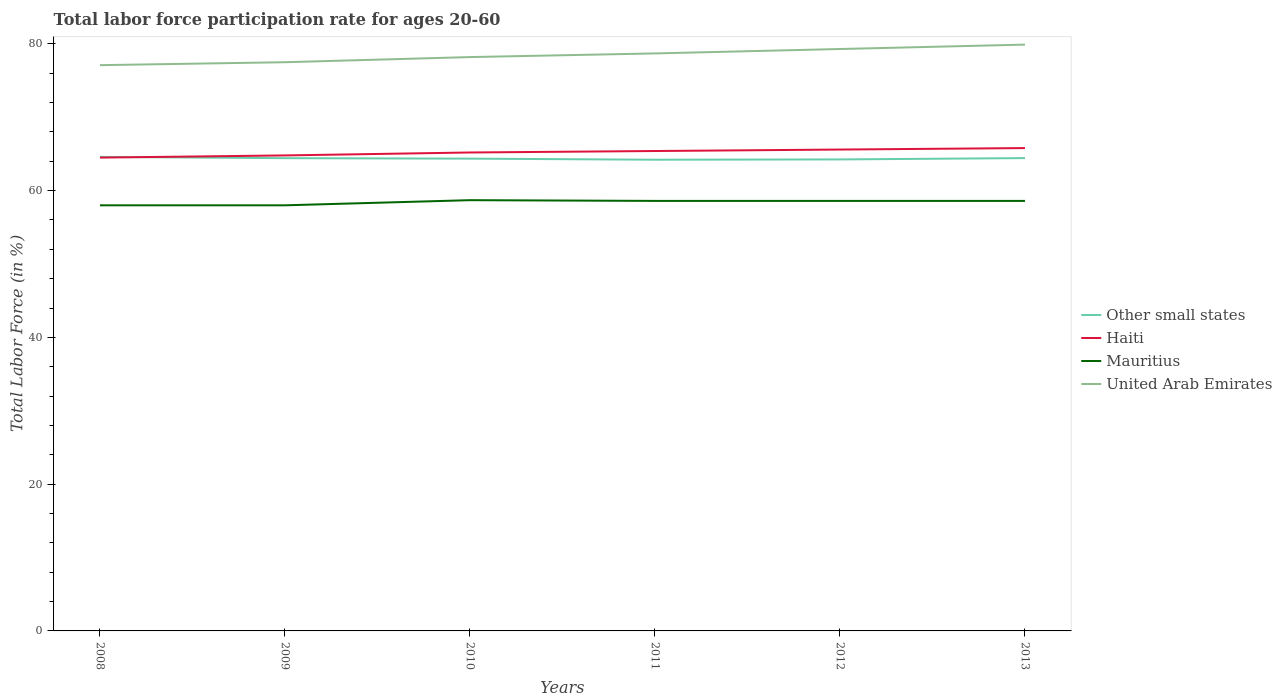Is the number of lines equal to the number of legend labels?
Give a very brief answer. Yes. Across all years, what is the maximum labor force participation rate in United Arab Emirates?
Offer a terse response. 77.1. In which year was the labor force participation rate in Mauritius maximum?
Give a very brief answer. 2008. What is the total labor force participation rate in United Arab Emirates in the graph?
Ensure brevity in your answer.  -1.8. What is the difference between the highest and the second highest labor force participation rate in Other small states?
Keep it short and to the point. 0.38. Is the labor force participation rate in United Arab Emirates strictly greater than the labor force participation rate in Haiti over the years?
Ensure brevity in your answer.  No. Are the values on the major ticks of Y-axis written in scientific E-notation?
Give a very brief answer. No. Does the graph contain any zero values?
Offer a terse response. No. Where does the legend appear in the graph?
Your answer should be very brief. Center right. How are the legend labels stacked?
Keep it short and to the point. Vertical. What is the title of the graph?
Offer a terse response. Total labor force participation rate for ages 20-60. Does "Curacao" appear as one of the legend labels in the graph?
Provide a short and direct response. No. What is the label or title of the X-axis?
Give a very brief answer. Years. What is the Total Labor Force (in %) of Other small states in 2008?
Your answer should be very brief. 64.6. What is the Total Labor Force (in %) in Haiti in 2008?
Offer a very short reply. 64.5. What is the Total Labor Force (in %) in Mauritius in 2008?
Ensure brevity in your answer.  58. What is the Total Labor Force (in %) of United Arab Emirates in 2008?
Ensure brevity in your answer.  77.1. What is the Total Labor Force (in %) in Other small states in 2009?
Your response must be concise. 64.42. What is the Total Labor Force (in %) in Haiti in 2009?
Provide a succinct answer. 64.8. What is the Total Labor Force (in %) of Mauritius in 2009?
Keep it short and to the point. 58. What is the Total Labor Force (in %) of United Arab Emirates in 2009?
Provide a succinct answer. 77.5. What is the Total Labor Force (in %) of Other small states in 2010?
Make the answer very short. 64.36. What is the Total Labor Force (in %) of Haiti in 2010?
Provide a succinct answer. 65.2. What is the Total Labor Force (in %) of Mauritius in 2010?
Make the answer very short. 58.7. What is the Total Labor Force (in %) in United Arab Emirates in 2010?
Offer a very short reply. 78.2. What is the Total Labor Force (in %) of Other small states in 2011?
Offer a very short reply. 64.21. What is the Total Labor Force (in %) of Haiti in 2011?
Offer a very short reply. 65.4. What is the Total Labor Force (in %) in Mauritius in 2011?
Keep it short and to the point. 58.6. What is the Total Labor Force (in %) of United Arab Emirates in 2011?
Provide a short and direct response. 78.7. What is the Total Labor Force (in %) of Other small states in 2012?
Make the answer very short. 64.25. What is the Total Labor Force (in %) of Haiti in 2012?
Offer a very short reply. 65.6. What is the Total Labor Force (in %) in Mauritius in 2012?
Your answer should be very brief. 58.6. What is the Total Labor Force (in %) in United Arab Emirates in 2012?
Provide a succinct answer. 79.3. What is the Total Labor Force (in %) in Other small states in 2013?
Provide a short and direct response. 64.44. What is the Total Labor Force (in %) of Haiti in 2013?
Offer a terse response. 65.8. What is the Total Labor Force (in %) in Mauritius in 2013?
Ensure brevity in your answer.  58.6. What is the Total Labor Force (in %) in United Arab Emirates in 2013?
Provide a short and direct response. 79.9. Across all years, what is the maximum Total Labor Force (in %) in Other small states?
Offer a very short reply. 64.6. Across all years, what is the maximum Total Labor Force (in %) in Haiti?
Ensure brevity in your answer.  65.8. Across all years, what is the maximum Total Labor Force (in %) of Mauritius?
Ensure brevity in your answer.  58.7. Across all years, what is the maximum Total Labor Force (in %) in United Arab Emirates?
Your answer should be compact. 79.9. Across all years, what is the minimum Total Labor Force (in %) in Other small states?
Your answer should be very brief. 64.21. Across all years, what is the minimum Total Labor Force (in %) of Haiti?
Make the answer very short. 64.5. Across all years, what is the minimum Total Labor Force (in %) of Mauritius?
Provide a succinct answer. 58. Across all years, what is the minimum Total Labor Force (in %) of United Arab Emirates?
Your answer should be very brief. 77.1. What is the total Total Labor Force (in %) in Other small states in the graph?
Provide a succinct answer. 386.29. What is the total Total Labor Force (in %) of Haiti in the graph?
Your response must be concise. 391.3. What is the total Total Labor Force (in %) of Mauritius in the graph?
Make the answer very short. 350.5. What is the total Total Labor Force (in %) of United Arab Emirates in the graph?
Give a very brief answer. 470.7. What is the difference between the Total Labor Force (in %) in Other small states in 2008 and that in 2009?
Your answer should be compact. 0.17. What is the difference between the Total Labor Force (in %) of Mauritius in 2008 and that in 2009?
Provide a succinct answer. 0. What is the difference between the Total Labor Force (in %) of United Arab Emirates in 2008 and that in 2009?
Provide a short and direct response. -0.4. What is the difference between the Total Labor Force (in %) in Other small states in 2008 and that in 2010?
Offer a very short reply. 0.24. What is the difference between the Total Labor Force (in %) of Haiti in 2008 and that in 2010?
Offer a terse response. -0.7. What is the difference between the Total Labor Force (in %) in Mauritius in 2008 and that in 2010?
Offer a terse response. -0.7. What is the difference between the Total Labor Force (in %) in Other small states in 2008 and that in 2011?
Ensure brevity in your answer.  0.38. What is the difference between the Total Labor Force (in %) in Mauritius in 2008 and that in 2011?
Provide a succinct answer. -0.6. What is the difference between the Total Labor Force (in %) in United Arab Emirates in 2008 and that in 2011?
Provide a short and direct response. -1.6. What is the difference between the Total Labor Force (in %) of Other small states in 2008 and that in 2012?
Make the answer very short. 0.34. What is the difference between the Total Labor Force (in %) in Haiti in 2008 and that in 2012?
Your answer should be compact. -1.1. What is the difference between the Total Labor Force (in %) in Other small states in 2008 and that in 2013?
Keep it short and to the point. 0.16. What is the difference between the Total Labor Force (in %) in Haiti in 2008 and that in 2013?
Give a very brief answer. -1.3. What is the difference between the Total Labor Force (in %) in Mauritius in 2008 and that in 2013?
Your answer should be very brief. -0.6. What is the difference between the Total Labor Force (in %) of United Arab Emirates in 2008 and that in 2013?
Your answer should be compact. -2.8. What is the difference between the Total Labor Force (in %) in Other small states in 2009 and that in 2010?
Make the answer very short. 0.06. What is the difference between the Total Labor Force (in %) in Haiti in 2009 and that in 2010?
Your answer should be very brief. -0.4. What is the difference between the Total Labor Force (in %) in United Arab Emirates in 2009 and that in 2010?
Provide a succinct answer. -0.7. What is the difference between the Total Labor Force (in %) of Other small states in 2009 and that in 2011?
Ensure brevity in your answer.  0.21. What is the difference between the Total Labor Force (in %) in United Arab Emirates in 2009 and that in 2011?
Offer a terse response. -1.2. What is the difference between the Total Labor Force (in %) of Other small states in 2009 and that in 2012?
Give a very brief answer. 0.17. What is the difference between the Total Labor Force (in %) of Haiti in 2009 and that in 2012?
Offer a terse response. -0.8. What is the difference between the Total Labor Force (in %) of Mauritius in 2009 and that in 2012?
Your answer should be very brief. -0.6. What is the difference between the Total Labor Force (in %) in United Arab Emirates in 2009 and that in 2012?
Your answer should be very brief. -1.8. What is the difference between the Total Labor Force (in %) in Other small states in 2009 and that in 2013?
Provide a succinct answer. -0.01. What is the difference between the Total Labor Force (in %) in Haiti in 2009 and that in 2013?
Your answer should be compact. -1. What is the difference between the Total Labor Force (in %) of Other small states in 2010 and that in 2011?
Offer a very short reply. 0.15. What is the difference between the Total Labor Force (in %) in Mauritius in 2010 and that in 2011?
Offer a very short reply. 0.1. What is the difference between the Total Labor Force (in %) of United Arab Emirates in 2010 and that in 2011?
Keep it short and to the point. -0.5. What is the difference between the Total Labor Force (in %) of Other small states in 2010 and that in 2012?
Your answer should be very brief. 0.11. What is the difference between the Total Labor Force (in %) of United Arab Emirates in 2010 and that in 2012?
Ensure brevity in your answer.  -1.1. What is the difference between the Total Labor Force (in %) of Other small states in 2010 and that in 2013?
Keep it short and to the point. -0.07. What is the difference between the Total Labor Force (in %) of Haiti in 2010 and that in 2013?
Your answer should be very brief. -0.6. What is the difference between the Total Labor Force (in %) in United Arab Emirates in 2010 and that in 2013?
Keep it short and to the point. -1.7. What is the difference between the Total Labor Force (in %) of Other small states in 2011 and that in 2012?
Make the answer very short. -0.04. What is the difference between the Total Labor Force (in %) of Mauritius in 2011 and that in 2012?
Give a very brief answer. 0. What is the difference between the Total Labor Force (in %) of United Arab Emirates in 2011 and that in 2012?
Keep it short and to the point. -0.6. What is the difference between the Total Labor Force (in %) in Other small states in 2011 and that in 2013?
Your answer should be very brief. -0.22. What is the difference between the Total Labor Force (in %) of Haiti in 2011 and that in 2013?
Provide a succinct answer. -0.4. What is the difference between the Total Labor Force (in %) in United Arab Emirates in 2011 and that in 2013?
Make the answer very short. -1.2. What is the difference between the Total Labor Force (in %) of Other small states in 2012 and that in 2013?
Your answer should be very brief. -0.18. What is the difference between the Total Labor Force (in %) in Haiti in 2012 and that in 2013?
Provide a short and direct response. -0.2. What is the difference between the Total Labor Force (in %) of Mauritius in 2012 and that in 2013?
Keep it short and to the point. 0. What is the difference between the Total Labor Force (in %) in Other small states in 2008 and the Total Labor Force (in %) in Haiti in 2009?
Keep it short and to the point. -0.2. What is the difference between the Total Labor Force (in %) in Other small states in 2008 and the Total Labor Force (in %) in Mauritius in 2009?
Make the answer very short. 6.6. What is the difference between the Total Labor Force (in %) in Other small states in 2008 and the Total Labor Force (in %) in United Arab Emirates in 2009?
Give a very brief answer. -12.9. What is the difference between the Total Labor Force (in %) in Haiti in 2008 and the Total Labor Force (in %) in United Arab Emirates in 2009?
Provide a short and direct response. -13. What is the difference between the Total Labor Force (in %) of Mauritius in 2008 and the Total Labor Force (in %) of United Arab Emirates in 2009?
Provide a short and direct response. -19.5. What is the difference between the Total Labor Force (in %) of Other small states in 2008 and the Total Labor Force (in %) of Haiti in 2010?
Provide a succinct answer. -0.6. What is the difference between the Total Labor Force (in %) in Other small states in 2008 and the Total Labor Force (in %) in Mauritius in 2010?
Provide a short and direct response. 5.9. What is the difference between the Total Labor Force (in %) in Other small states in 2008 and the Total Labor Force (in %) in United Arab Emirates in 2010?
Your answer should be compact. -13.6. What is the difference between the Total Labor Force (in %) of Haiti in 2008 and the Total Labor Force (in %) of Mauritius in 2010?
Provide a short and direct response. 5.8. What is the difference between the Total Labor Force (in %) of Haiti in 2008 and the Total Labor Force (in %) of United Arab Emirates in 2010?
Keep it short and to the point. -13.7. What is the difference between the Total Labor Force (in %) of Mauritius in 2008 and the Total Labor Force (in %) of United Arab Emirates in 2010?
Make the answer very short. -20.2. What is the difference between the Total Labor Force (in %) of Other small states in 2008 and the Total Labor Force (in %) of Haiti in 2011?
Provide a succinct answer. -0.8. What is the difference between the Total Labor Force (in %) in Other small states in 2008 and the Total Labor Force (in %) in Mauritius in 2011?
Ensure brevity in your answer.  6. What is the difference between the Total Labor Force (in %) in Other small states in 2008 and the Total Labor Force (in %) in United Arab Emirates in 2011?
Your answer should be compact. -14.1. What is the difference between the Total Labor Force (in %) in Mauritius in 2008 and the Total Labor Force (in %) in United Arab Emirates in 2011?
Provide a succinct answer. -20.7. What is the difference between the Total Labor Force (in %) in Other small states in 2008 and the Total Labor Force (in %) in Haiti in 2012?
Your response must be concise. -1. What is the difference between the Total Labor Force (in %) in Other small states in 2008 and the Total Labor Force (in %) in Mauritius in 2012?
Provide a succinct answer. 6. What is the difference between the Total Labor Force (in %) in Other small states in 2008 and the Total Labor Force (in %) in United Arab Emirates in 2012?
Provide a succinct answer. -14.7. What is the difference between the Total Labor Force (in %) in Haiti in 2008 and the Total Labor Force (in %) in Mauritius in 2012?
Give a very brief answer. 5.9. What is the difference between the Total Labor Force (in %) in Haiti in 2008 and the Total Labor Force (in %) in United Arab Emirates in 2012?
Make the answer very short. -14.8. What is the difference between the Total Labor Force (in %) in Mauritius in 2008 and the Total Labor Force (in %) in United Arab Emirates in 2012?
Ensure brevity in your answer.  -21.3. What is the difference between the Total Labor Force (in %) of Other small states in 2008 and the Total Labor Force (in %) of Haiti in 2013?
Keep it short and to the point. -1.2. What is the difference between the Total Labor Force (in %) in Other small states in 2008 and the Total Labor Force (in %) in Mauritius in 2013?
Make the answer very short. 6. What is the difference between the Total Labor Force (in %) of Other small states in 2008 and the Total Labor Force (in %) of United Arab Emirates in 2013?
Provide a succinct answer. -15.3. What is the difference between the Total Labor Force (in %) of Haiti in 2008 and the Total Labor Force (in %) of United Arab Emirates in 2013?
Your answer should be very brief. -15.4. What is the difference between the Total Labor Force (in %) in Mauritius in 2008 and the Total Labor Force (in %) in United Arab Emirates in 2013?
Offer a very short reply. -21.9. What is the difference between the Total Labor Force (in %) of Other small states in 2009 and the Total Labor Force (in %) of Haiti in 2010?
Keep it short and to the point. -0.78. What is the difference between the Total Labor Force (in %) of Other small states in 2009 and the Total Labor Force (in %) of Mauritius in 2010?
Ensure brevity in your answer.  5.72. What is the difference between the Total Labor Force (in %) of Other small states in 2009 and the Total Labor Force (in %) of United Arab Emirates in 2010?
Your answer should be compact. -13.78. What is the difference between the Total Labor Force (in %) of Haiti in 2009 and the Total Labor Force (in %) of Mauritius in 2010?
Ensure brevity in your answer.  6.1. What is the difference between the Total Labor Force (in %) of Mauritius in 2009 and the Total Labor Force (in %) of United Arab Emirates in 2010?
Keep it short and to the point. -20.2. What is the difference between the Total Labor Force (in %) in Other small states in 2009 and the Total Labor Force (in %) in Haiti in 2011?
Offer a terse response. -0.98. What is the difference between the Total Labor Force (in %) in Other small states in 2009 and the Total Labor Force (in %) in Mauritius in 2011?
Make the answer very short. 5.82. What is the difference between the Total Labor Force (in %) of Other small states in 2009 and the Total Labor Force (in %) of United Arab Emirates in 2011?
Keep it short and to the point. -14.28. What is the difference between the Total Labor Force (in %) of Haiti in 2009 and the Total Labor Force (in %) of Mauritius in 2011?
Your answer should be very brief. 6.2. What is the difference between the Total Labor Force (in %) in Mauritius in 2009 and the Total Labor Force (in %) in United Arab Emirates in 2011?
Provide a succinct answer. -20.7. What is the difference between the Total Labor Force (in %) in Other small states in 2009 and the Total Labor Force (in %) in Haiti in 2012?
Offer a very short reply. -1.18. What is the difference between the Total Labor Force (in %) of Other small states in 2009 and the Total Labor Force (in %) of Mauritius in 2012?
Give a very brief answer. 5.82. What is the difference between the Total Labor Force (in %) in Other small states in 2009 and the Total Labor Force (in %) in United Arab Emirates in 2012?
Your answer should be compact. -14.88. What is the difference between the Total Labor Force (in %) in Haiti in 2009 and the Total Labor Force (in %) in United Arab Emirates in 2012?
Your answer should be very brief. -14.5. What is the difference between the Total Labor Force (in %) in Mauritius in 2009 and the Total Labor Force (in %) in United Arab Emirates in 2012?
Ensure brevity in your answer.  -21.3. What is the difference between the Total Labor Force (in %) in Other small states in 2009 and the Total Labor Force (in %) in Haiti in 2013?
Ensure brevity in your answer.  -1.38. What is the difference between the Total Labor Force (in %) in Other small states in 2009 and the Total Labor Force (in %) in Mauritius in 2013?
Make the answer very short. 5.82. What is the difference between the Total Labor Force (in %) in Other small states in 2009 and the Total Labor Force (in %) in United Arab Emirates in 2013?
Ensure brevity in your answer.  -15.48. What is the difference between the Total Labor Force (in %) of Haiti in 2009 and the Total Labor Force (in %) of United Arab Emirates in 2013?
Offer a very short reply. -15.1. What is the difference between the Total Labor Force (in %) of Mauritius in 2009 and the Total Labor Force (in %) of United Arab Emirates in 2013?
Your answer should be compact. -21.9. What is the difference between the Total Labor Force (in %) in Other small states in 2010 and the Total Labor Force (in %) in Haiti in 2011?
Keep it short and to the point. -1.04. What is the difference between the Total Labor Force (in %) in Other small states in 2010 and the Total Labor Force (in %) in Mauritius in 2011?
Provide a short and direct response. 5.76. What is the difference between the Total Labor Force (in %) in Other small states in 2010 and the Total Labor Force (in %) in United Arab Emirates in 2011?
Give a very brief answer. -14.34. What is the difference between the Total Labor Force (in %) in Haiti in 2010 and the Total Labor Force (in %) in Mauritius in 2011?
Make the answer very short. 6.6. What is the difference between the Total Labor Force (in %) of Haiti in 2010 and the Total Labor Force (in %) of United Arab Emirates in 2011?
Provide a succinct answer. -13.5. What is the difference between the Total Labor Force (in %) in Other small states in 2010 and the Total Labor Force (in %) in Haiti in 2012?
Provide a short and direct response. -1.24. What is the difference between the Total Labor Force (in %) of Other small states in 2010 and the Total Labor Force (in %) of Mauritius in 2012?
Give a very brief answer. 5.76. What is the difference between the Total Labor Force (in %) of Other small states in 2010 and the Total Labor Force (in %) of United Arab Emirates in 2012?
Keep it short and to the point. -14.94. What is the difference between the Total Labor Force (in %) in Haiti in 2010 and the Total Labor Force (in %) in United Arab Emirates in 2012?
Make the answer very short. -14.1. What is the difference between the Total Labor Force (in %) of Mauritius in 2010 and the Total Labor Force (in %) of United Arab Emirates in 2012?
Offer a terse response. -20.6. What is the difference between the Total Labor Force (in %) in Other small states in 2010 and the Total Labor Force (in %) in Haiti in 2013?
Keep it short and to the point. -1.44. What is the difference between the Total Labor Force (in %) in Other small states in 2010 and the Total Labor Force (in %) in Mauritius in 2013?
Provide a short and direct response. 5.76. What is the difference between the Total Labor Force (in %) in Other small states in 2010 and the Total Labor Force (in %) in United Arab Emirates in 2013?
Your response must be concise. -15.54. What is the difference between the Total Labor Force (in %) of Haiti in 2010 and the Total Labor Force (in %) of United Arab Emirates in 2013?
Keep it short and to the point. -14.7. What is the difference between the Total Labor Force (in %) in Mauritius in 2010 and the Total Labor Force (in %) in United Arab Emirates in 2013?
Ensure brevity in your answer.  -21.2. What is the difference between the Total Labor Force (in %) of Other small states in 2011 and the Total Labor Force (in %) of Haiti in 2012?
Provide a short and direct response. -1.39. What is the difference between the Total Labor Force (in %) of Other small states in 2011 and the Total Labor Force (in %) of Mauritius in 2012?
Make the answer very short. 5.61. What is the difference between the Total Labor Force (in %) of Other small states in 2011 and the Total Labor Force (in %) of United Arab Emirates in 2012?
Provide a succinct answer. -15.09. What is the difference between the Total Labor Force (in %) of Haiti in 2011 and the Total Labor Force (in %) of United Arab Emirates in 2012?
Ensure brevity in your answer.  -13.9. What is the difference between the Total Labor Force (in %) of Mauritius in 2011 and the Total Labor Force (in %) of United Arab Emirates in 2012?
Offer a terse response. -20.7. What is the difference between the Total Labor Force (in %) in Other small states in 2011 and the Total Labor Force (in %) in Haiti in 2013?
Offer a terse response. -1.59. What is the difference between the Total Labor Force (in %) of Other small states in 2011 and the Total Labor Force (in %) of Mauritius in 2013?
Keep it short and to the point. 5.61. What is the difference between the Total Labor Force (in %) of Other small states in 2011 and the Total Labor Force (in %) of United Arab Emirates in 2013?
Provide a succinct answer. -15.69. What is the difference between the Total Labor Force (in %) of Haiti in 2011 and the Total Labor Force (in %) of Mauritius in 2013?
Make the answer very short. 6.8. What is the difference between the Total Labor Force (in %) of Mauritius in 2011 and the Total Labor Force (in %) of United Arab Emirates in 2013?
Keep it short and to the point. -21.3. What is the difference between the Total Labor Force (in %) of Other small states in 2012 and the Total Labor Force (in %) of Haiti in 2013?
Offer a very short reply. -1.55. What is the difference between the Total Labor Force (in %) in Other small states in 2012 and the Total Labor Force (in %) in Mauritius in 2013?
Keep it short and to the point. 5.65. What is the difference between the Total Labor Force (in %) in Other small states in 2012 and the Total Labor Force (in %) in United Arab Emirates in 2013?
Your response must be concise. -15.65. What is the difference between the Total Labor Force (in %) of Haiti in 2012 and the Total Labor Force (in %) of Mauritius in 2013?
Make the answer very short. 7. What is the difference between the Total Labor Force (in %) of Haiti in 2012 and the Total Labor Force (in %) of United Arab Emirates in 2013?
Provide a short and direct response. -14.3. What is the difference between the Total Labor Force (in %) in Mauritius in 2012 and the Total Labor Force (in %) in United Arab Emirates in 2013?
Your answer should be compact. -21.3. What is the average Total Labor Force (in %) of Other small states per year?
Your answer should be very brief. 64.38. What is the average Total Labor Force (in %) in Haiti per year?
Ensure brevity in your answer.  65.22. What is the average Total Labor Force (in %) in Mauritius per year?
Give a very brief answer. 58.42. What is the average Total Labor Force (in %) of United Arab Emirates per year?
Give a very brief answer. 78.45. In the year 2008, what is the difference between the Total Labor Force (in %) in Other small states and Total Labor Force (in %) in Haiti?
Provide a succinct answer. 0.1. In the year 2008, what is the difference between the Total Labor Force (in %) of Other small states and Total Labor Force (in %) of Mauritius?
Give a very brief answer. 6.6. In the year 2008, what is the difference between the Total Labor Force (in %) of Other small states and Total Labor Force (in %) of United Arab Emirates?
Your answer should be very brief. -12.5. In the year 2008, what is the difference between the Total Labor Force (in %) of Mauritius and Total Labor Force (in %) of United Arab Emirates?
Your answer should be very brief. -19.1. In the year 2009, what is the difference between the Total Labor Force (in %) in Other small states and Total Labor Force (in %) in Haiti?
Make the answer very short. -0.38. In the year 2009, what is the difference between the Total Labor Force (in %) of Other small states and Total Labor Force (in %) of Mauritius?
Offer a terse response. 6.42. In the year 2009, what is the difference between the Total Labor Force (in %) in Other small states and Total Labor Force (in %) in United Arab Emirates?
Your response must be concise. -13.08. In the year 2009, what is the difference between the Total Labor Force (in %) of Haiti and Total Labor Force (in %) of United Arab Emirates?
Your response must be concise. -12.7. In the year 2009, what is the difference between the Total Labor Force (in %) in Mauritius and Total Labor Force (in %) in United Arab Emirates?
Offer a very short reply. -19.5. In the year 2010, what is the difference between the Total Labor Force (in %) in Other small states and Total Labor Force (in %) in Haiti?
Make the answer very short. -0.84. In the year 2010, what is the difference between the Total Labor Force (in %) of Other small states and Total Labor Force (in %) of Mauritius?
Keep it short and to the point. 5.66. In the year 2010, what is the difference between the Total Labor Force (in %) of Other small states and Total Labor Force (in %) of United Arab Emirates?
Your response must be concise. -13.84. In the year 2010, what is the difference between the Total Labor Force (in %) of Mauritius and Total Labor Force (in %) of United Arab Emirates?
Your response must be concise. -19.5. In the year 2011, what is the difference between the Total Labor Force (in %) in Other small states and Total Labor Force (in %) in Haiti?
Give a very brief answer. -1.19. In the year 2011, what is the difference between the Total Labor Force (in %) in Other small states and Total Labor Force (in %) in Mauritius?
Provide a succinct answer. 5.61. In the year 2011, what is the difference between the Total Labor Force (in %) in Other small states and Total Labor Force (in %) in United Arab Emirates?
Your response must be concise. -14.49. In the year 2011, what is the difference between the Total Labor Force (in %) of Haiti and Total Labor Force (in %) of Mauritius?
Provide a succinct answer. 6.8. In the year 2011, what is the difference between the Total Labor Force (in %) of Haiti and Total Labor Force (in %) of United Arab Emirates?
Your response must be concise. -13.3. In the year 2011, what is the difference between the Total Labor Force (in %) of Mauritius and Total Labor Force (in %) of United Arab Emirates?
Your answer should be compact. -20.1. In the year 2012, what is the difference between the Total Labor Force (in %) in Other small states and Total Labor Force (in %) in Haiti?
Offer a very short reply. -1.35. In the year 2012, what is the difference between the Total Labor Force (in %) of Other small states and Total Labor Force (in %) of Mauritius?
Your response must be concise. 5.65. In the year 2012, what is the difference between the Total Labor Force (in %) of Other small states and Total Labor Force (in %) of United Arab Emirates?
Your answer should be compact. -15.05. In the year 2012, what is the difference between the Total Labor Force (in %) in Haiti and Total Labor Force (in %) in Mauritius?
Make the answer very short. 7. In the year 2012, what is the difference between the Total Labor Force (in %) in Haiti and Total Labor Force (in %) in United Arab Emirates?
Make the answer very short. -13.7. In the year 2012, what is the difference between the Total Labor Force (in %) in Mauritius and Total Labor Force (in %) in United Arab Emirates?
Your answer should be very brief. -20.7. In the year 2013, what is the difference between the Total Labor Force (in %) in Other small states and Total Labor Force (in %) in Haiti?
Make the answer very short. -1.36. In the year 2013, what is the difference between the Total Labor Force (in %) of Other small states and Total Labor Force (in %) of Mauritius?
Your answer should be very brief. 5.84. In the year 2013, what is the difference between the Total Labor Force (in %) in Other small states and Total Labor Force (in %) in United Arab Emirates?
Keep it short and to the point. -15.46. In the year 2013, what is the difference between the Total Labor Force (in %) in Haiti and Total Labor Force (in %) in United Arab Emirates?
Provide a short and direct response. -14.1. In the year 2013, what is the difference between the Total Labor Force (in %) of Mauritius and Total Labor Force (in %) of United Arab Emirates?
Keep it short and to the point. -21.3. What is the ratio of the Total Labor Force (in %) of Haiti in 2008 to that in 2009?
Make the answer very short. 1. What is the ratio of the Total Labor Force (in %) of Mauritius in 2008 to that in 2009?
Give a very brief answer. 1. What is the ratio of the Total Labor Force (in %) of United Arab Emirates in 2008 to that in 2009?
Ensure brevity in your answer.  0.99. What is the ratio of the Total Labor Force (in %) of Haiti in 2008 to that in 2010?
Your answer should be very brief. 0.99. What is the ratio of the Total Labor Force (in %) in United Arab Emirates in 2008 to that in 2010?
Your answer should be compact. 0.99. What is the ratio of the Total Labor Force (in %) of Other small states in 2008 to that in 2011?
Offer a very short reply. 1.01. What is the ratio of the Total Labor Force (in %) of Haiti in 2008 to that in 2011?
Offer a very short reply. 0.99. What is the ratio of the Total Labor Force (in %) in United Arab Emirates in 2008 to that in 2011?
Provide a short and direct response. 0.98. What is the ratio of the Total Labor Force (in %) of Other small states in 2008 to that in 2012?
Offer a very short reply. 1.01. What is the ratio of the Total Labor Force (in %) of Haiti in 2008 to that in 2012?
Offer a very short reply. 0.98. What is the ratio of the Total Labor Force (in %) in Mauritius in 2008 to that in 2012?
Make the answer very short. 0.99. What is the ratio of the Total Labor Force (in %) in United Arab Emirates in 2008 to that in 2012?
Offer a terse response. 0.97. What is the ratio of the Total Labor Force (in %) in Haiti in 2008 to that in 2013?
Provide a short and direct response. 0.98. What is the ratio of the Total Labor Force (in %) in Other small states in 2009 to that in 2011?
Keep it short and to the point. 1. What is the ratio of the Total Labor Force (in %) in Haiti in 2009 to that in 2011?
Offer a very short reply. 0.99. What is the ratio of the Total Labor Force (in %) in Mauritius in 2009 to that in 2011?
Ensure brevity in your answer.  0.99. What is the ratio of the Total Labor Force (in %) in United Arab Emirates in 2009 to that in 2011?
Make the answer very short. 0.98. What is the ratio of the Total Labor Force (in %) in Other small states in 2009 to that in 2012?
Keep it short and to the point. 1. What is the ratio of the Total Labor Force (in %) in Haiti in 2009 to that in 2012?
Give a very brief answer. 0.99. What is the ratio of the Total Labor Force (in %) of Mauritius in 2009 to that in 2012?
Offer a terse response. 0.99. What is the ratio of the Total Labor Force (in %) of United Arab Emirates in 2009 to that in 2012?
Offer a terse response. 0.98. What is the ratio of the Total Labor Force (in %) in Mauritius in 2009 to that in 2013?
Make the answer very short. 0.99. What is the ratio of the Total Labor Force (in %) of United Arab Emirates in 2010 to that in 2012?
Provide a succinct answer. 0.99. What is the ratio of the Total Labor Force (in %) of Other small states in 2010 to that in 2013?
Provide a short and direct response. 1. What is the ratio of the Total Labor Force (in %) of Haiti in 2010 to that in 2013?
Keep it short and to the point. 0.99. What is the ratio of the Total Labor Force (in %) in Mauritius in 2010 to that in 2013?
Ensure brevity in your answer.  1. What is the ratio of the Total Labor Force (in %) in United Arab Emirates in 2010 to that in 2013?
Give a very brief answer. 0.98. What is the ratio of the Total Labor Force (in %) in Other small states in 2012 to that in 2013?
Keep it short and to the point. 1. What is the ratio of the Total Labor Force (in %) in Haiti in 2012 to that in 2013?
Your answer should be compact. 1. What is the ratio of the Total Labor Force (in %) in United Arab Emirates in 2012 to that in 2013?
Make the answer very short. 0.99. What is the difference between the highest and the second highest Total Labor Force (in %) of Other small states?
Provide a short and direct response. 0.16. What is the difference between the highest and the second highest Total Labor Force (in %) in Haiti?
Provide a succinct answer. 0.2. What is the difference between the highest and the second highest Total Labor Force (in %) of Mauritius?
Provide a succinct answer. 0.1. What is the difference between the highest and the second highest Total Labor Force (in %) in United Arab Emirates?
Your response must be concise. 0.6. What is the difference between the highest and the lowest Total Labor Force (in %) of Other small states?
Your answer should be very brief. 0.38. What is the difference between the highest and the lowest Total Labor Force (in %) in Haiti?
Your answer should be very brief. 1.3. What is the difference between the highest and the lowest Total Labor Force (in %) of Mauritius?
Offer a very short reply. 0.7. What is the difference between the highest and the lowest Total Labor Force (in %) of United Arab Emirates?
Offer a very short reply. 2.8. 